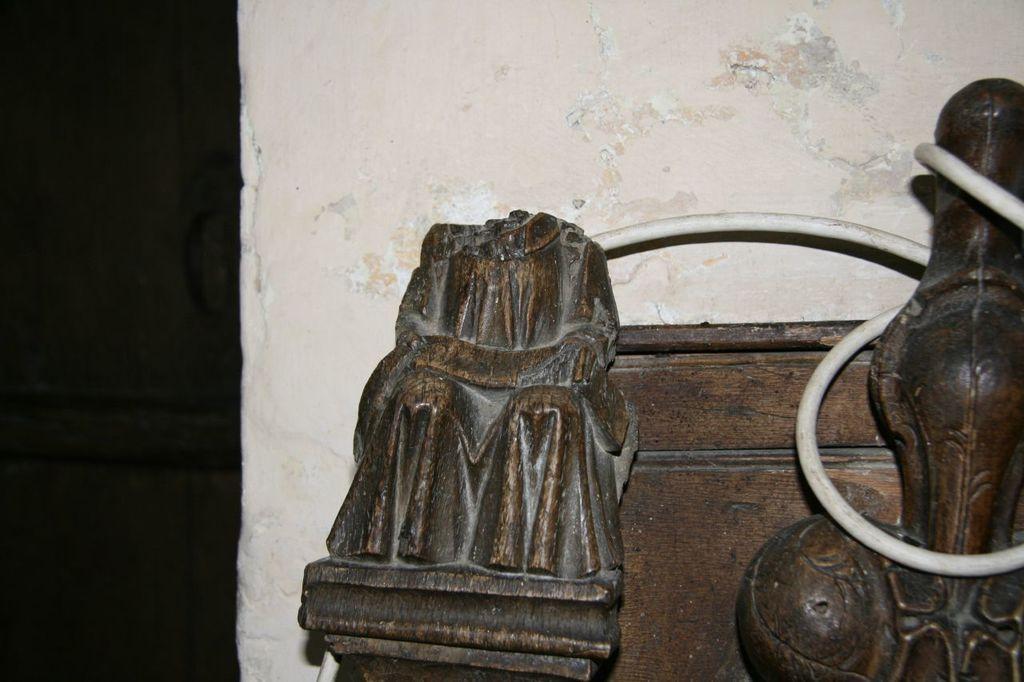Please provide a concise description of this image. In the front of the image there are wooden objects. In the background of the image there is a wall. 